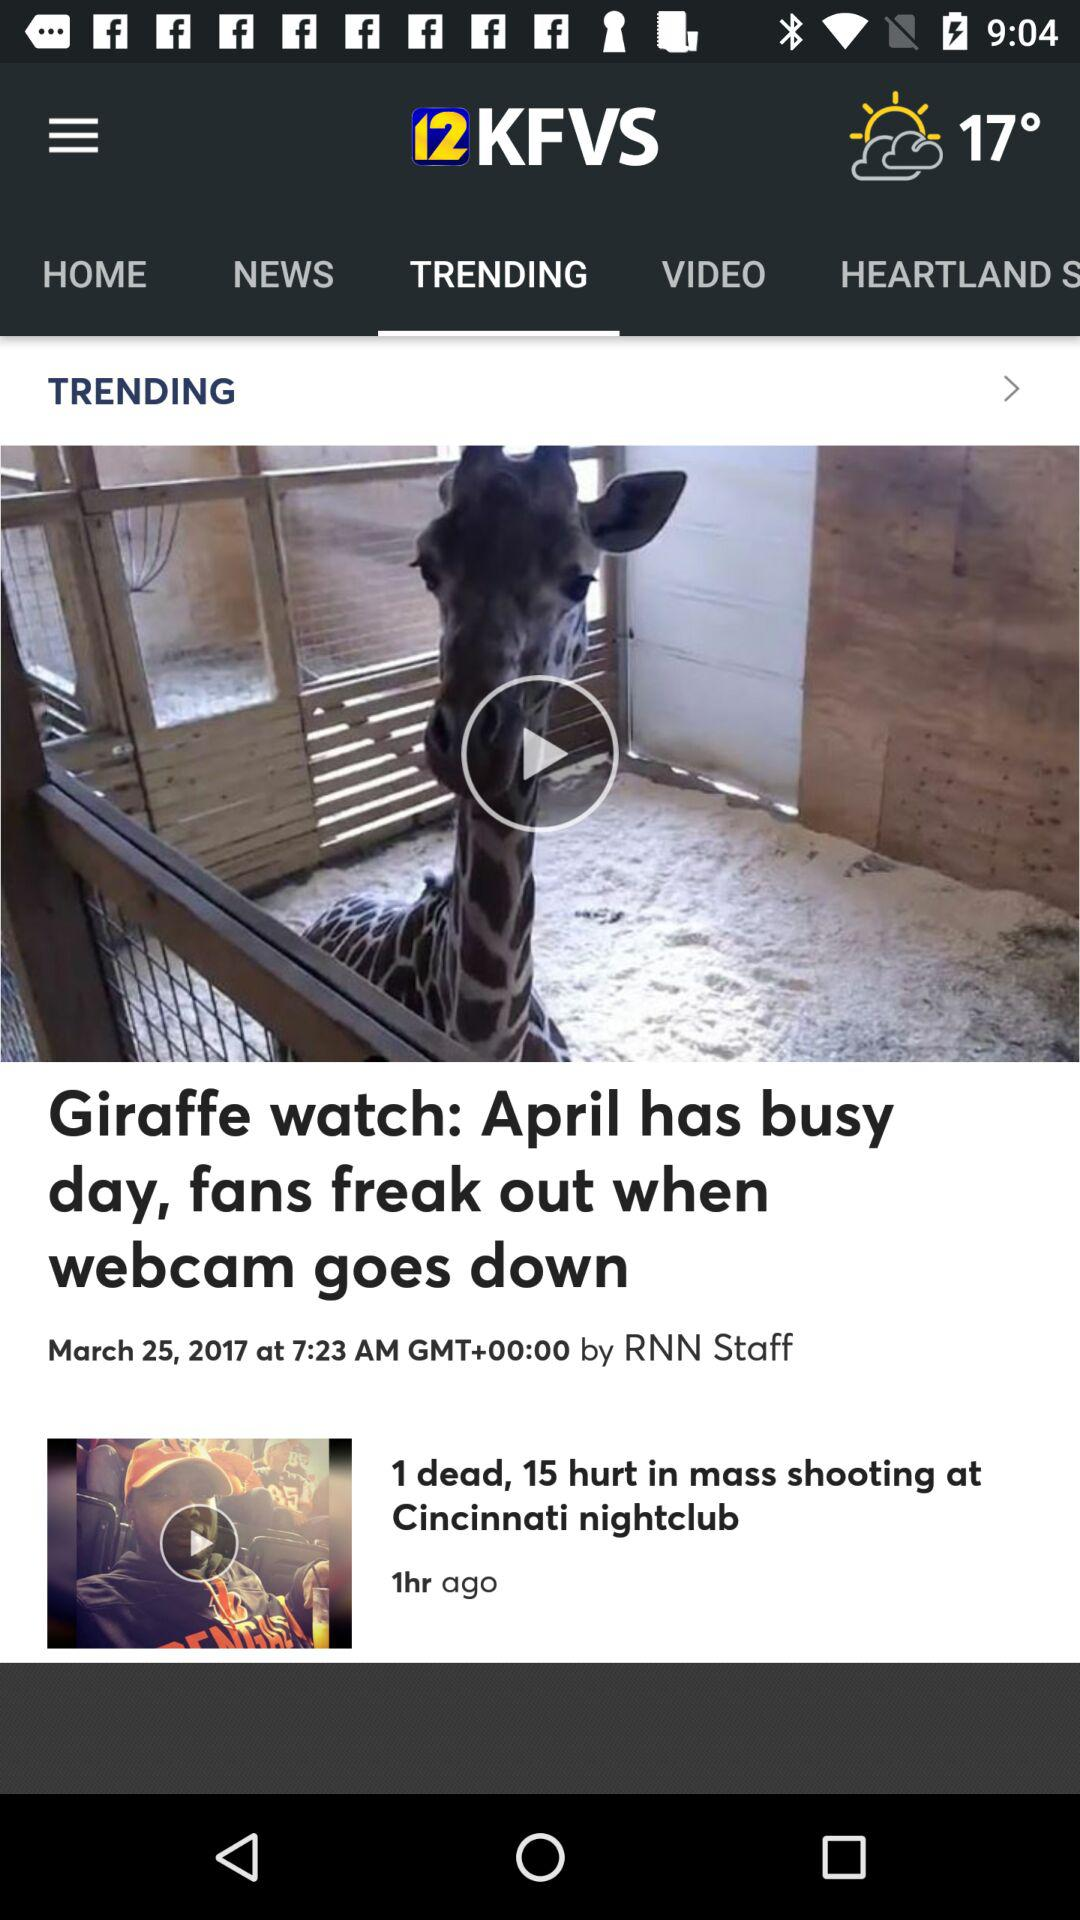Who posted the video about the Giraffe watch? The video was posted by RNN Staff. 